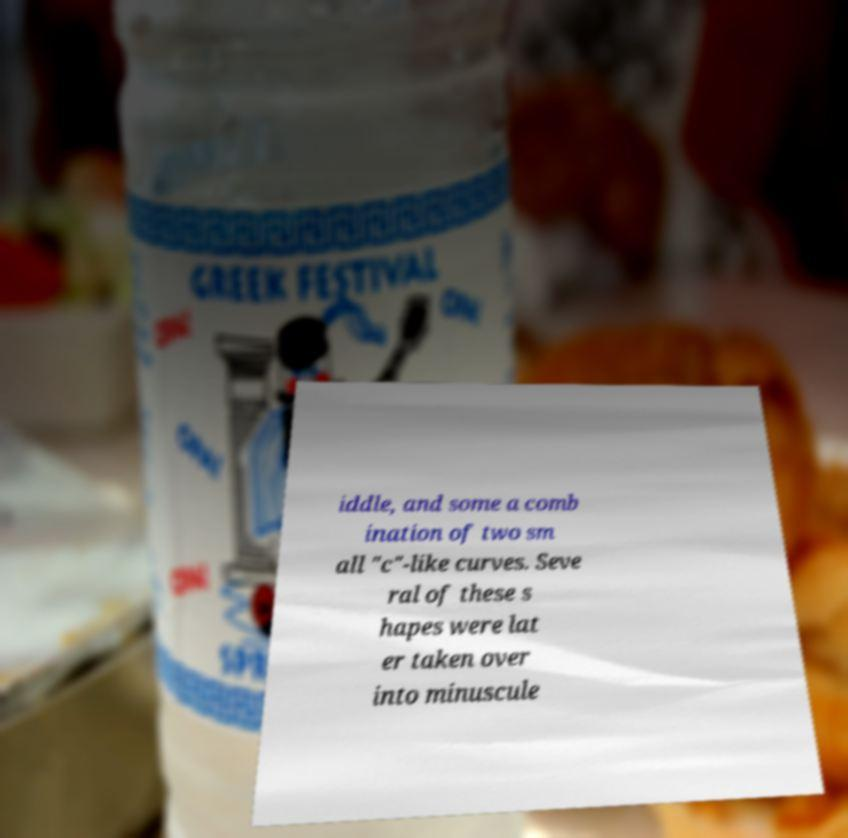Could you assist in decoding the text presented in this image and type it out clearly? iddle, and some a comb ination of two sm all "c"-like curves. Seve ral of these s hapes were lat er taken over into minuscule 